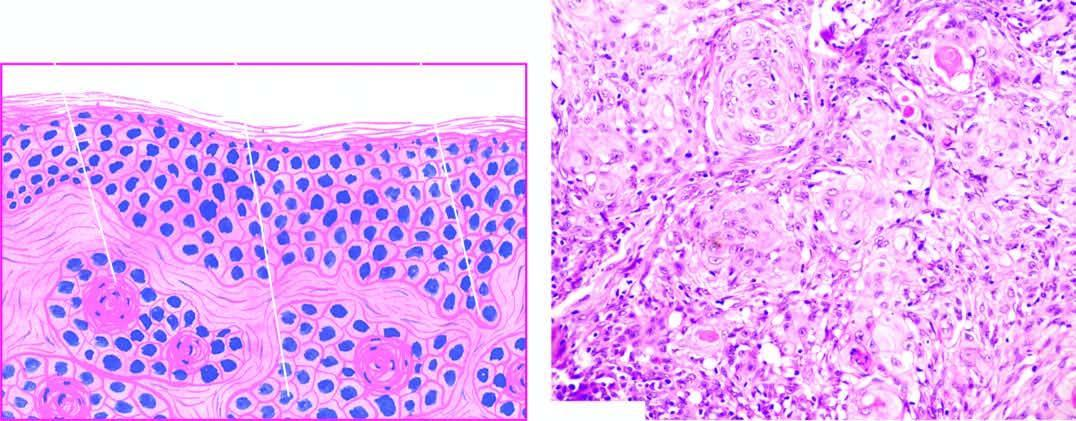does the deposition show whorls of malignant squamous cells with central keratin pearls?
Answer the question using a single word or phrase. No 